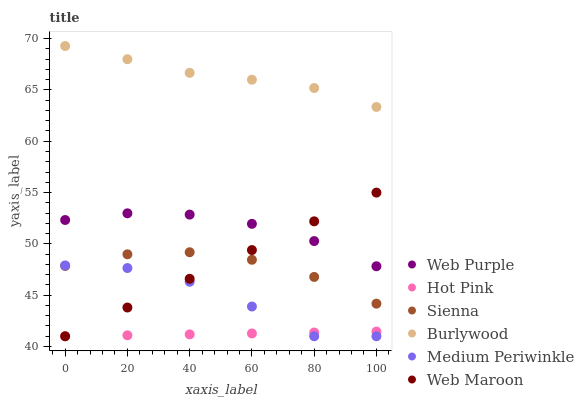Does Hot Pink have the minimum area under the curve?
Answer yes or no. Yes. Does Burlywood have the maximum area under the curve?
Answer yes or no. Yes. Does Web Maroon have the minimum area under the curve?
Answer yes or no. No. Does Web Maroon have the maximum area under the curve?
Answer yes or no. No. Is Hot Pink the smoothest?
Answer yes or no. Yes. Is Medium Periwinkle the roughest?
Answer yes or no. Yes. Is Web Maroon the smoothest?
Answer yes or no. No. Is Web Maroon the roughest?
Answer yes or no. No. Does Web Maroon have the lowest value?
Answer yes or no. Yes. Does Sienna have the lowest value?
Answer yes or no. No. Does Burlywood have the highest value?
Answer yes or no. Yes. Does Web Maroon have the highest value?
Answer yes or no. No. Is Web Purple less than Burlywood?
Answer yes or no. Yes. Is Burlywood greater than Hot Pink?
Answer yes or no. Yes. Does Web Maroon intersect Web Purple?
Answer yes or no. Yes. Is Web Maroon less than Web Purple?
Answer yes or no. No. Is Web Maroon greater than Web Purple?
Answer yes or no. No. Does Web Purple intersect Burlywood?
Answer yes or no. No. 